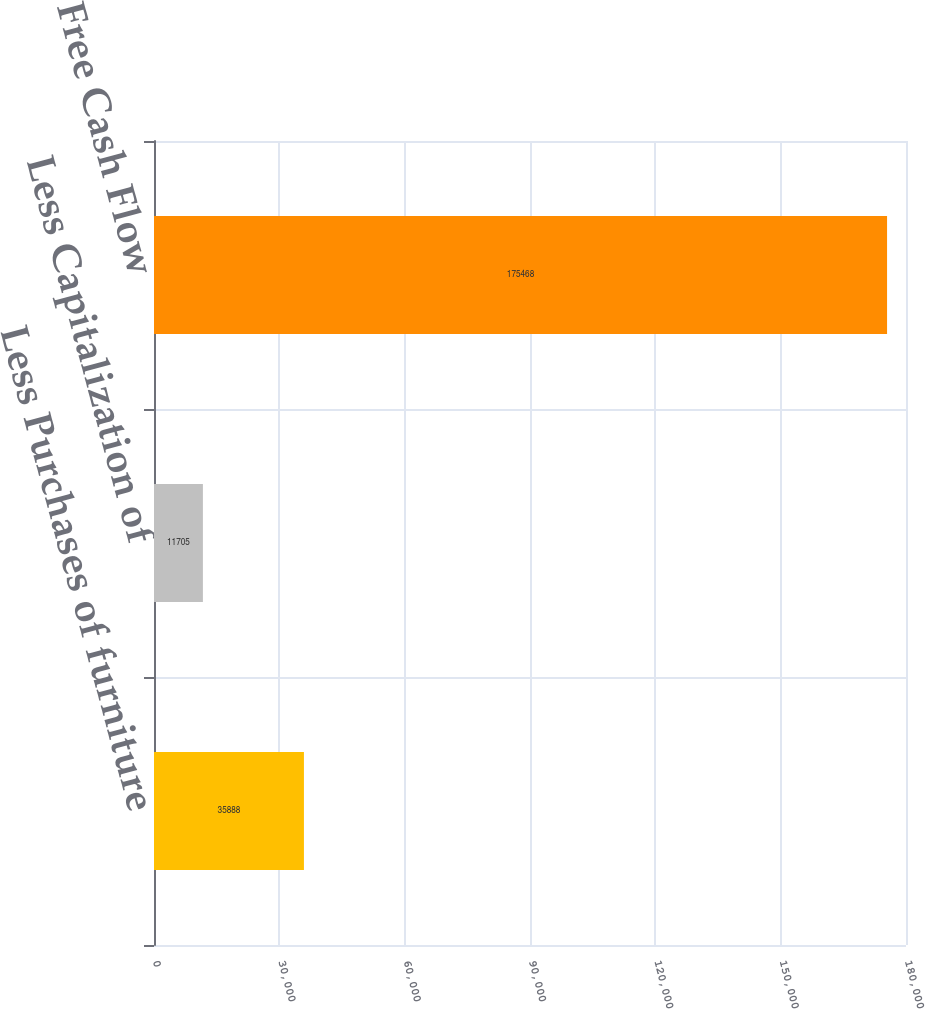Convert chart to OTSL. <chart><loc_0><loc_0><loc_500><loc_500><bar_chart><fcel>Less Purchases of furniture<fcel>Less Capitalization of<fcel>Free Cash Flow<nl><fcel>35888<fcel>11705<fcel>175468<nl></chart> 